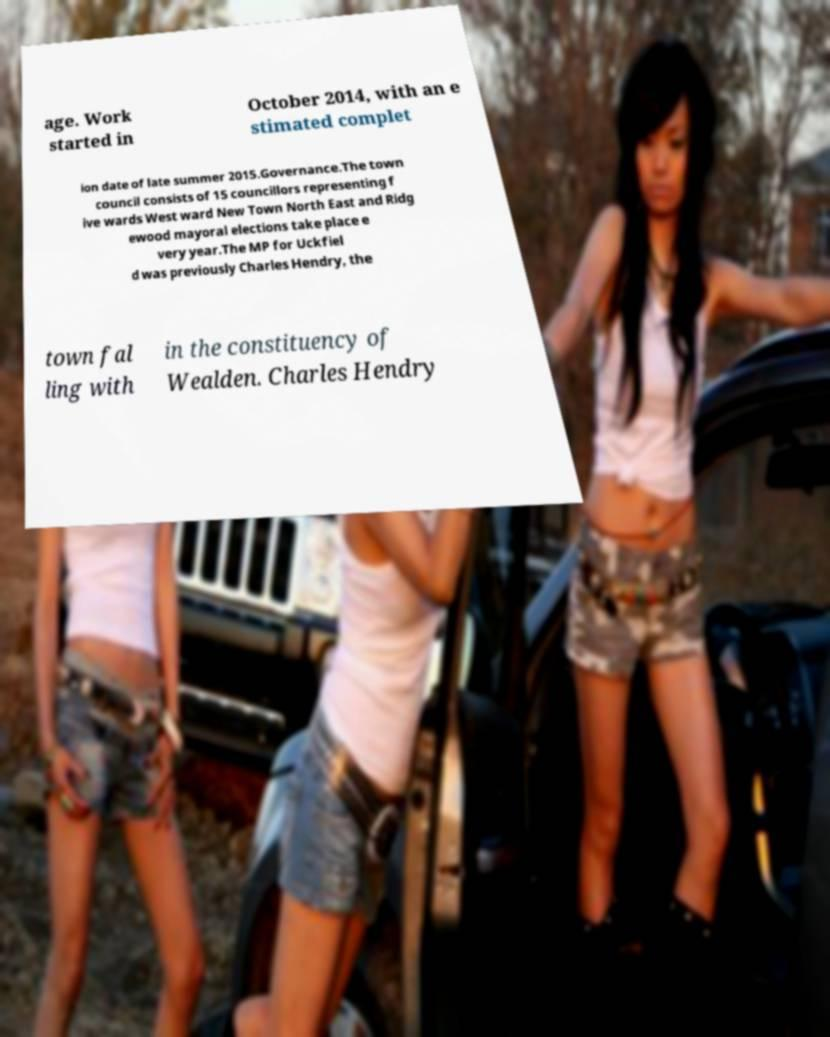Please identify and transcribe the text found in this image. age. Work started in October 2014, with an e stimated complet ion date of late summer 2015.Governance.The town council consists of 15 councillors representing f ive wards West ward New Town North East and Ridg ewood mayoral elections take place e very year.The MP for Uckfiel d was previously Charles Hendry, the town fal ling with in the constituency of Wealden. Charles Hendry 